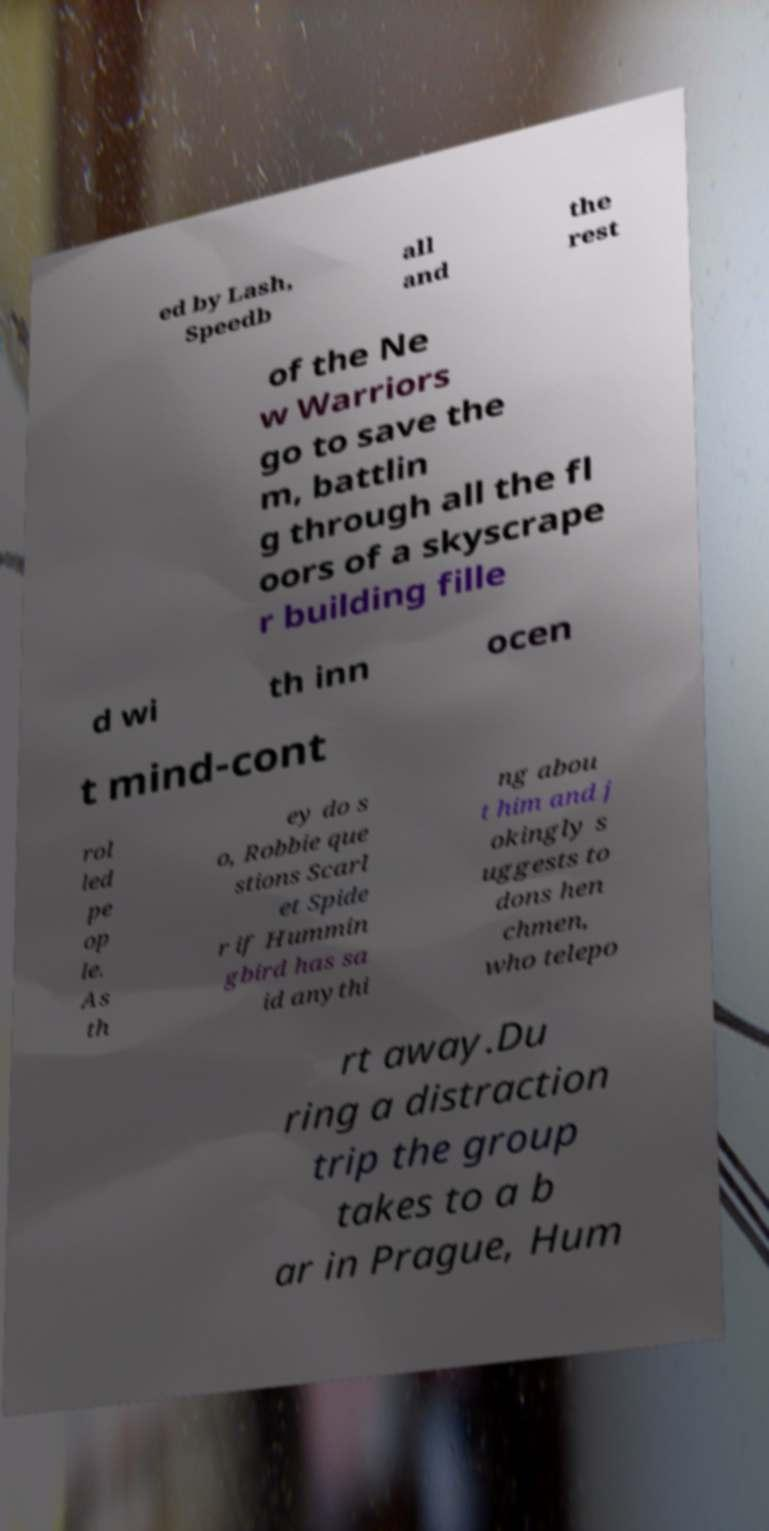I need the written content from this picture converted into text. Can you do that? ed by Lash, Speedb all and the rest of the Ne w Warriors go to save the m, battlin g through all the fl oors of a skyscrape r building fille d wi th inn ocen t mind-cont rol led pe op le. As th ey do s o, Robbie que stions Scarl et Spide r if Hummin gbird has sa id anythi ng abou t him and j okingly s uggests to dons hen chmen, who telepo rt away.Du ring a distraction trip the group takes to a b ar in Prague, Hum 